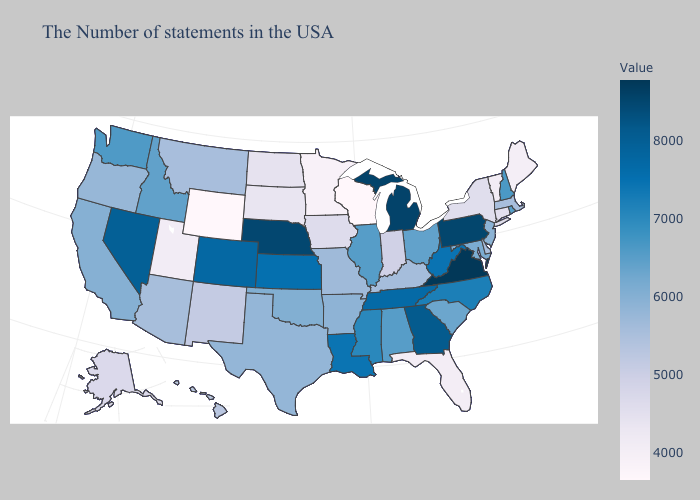Is the legend a continuous bar?
Write a very short answer. Yes. Among the states that border Arizona , does New Mexico have the lowest value?
Write a very short answer. No. Does Wyoming have the lowest value in the USA?
Write a very short answer. Yes. Which states have the lowest value in the West?
Concise answer only. Wyoming. Among the states that border Delaware , which have the lowest value?
Concise answer only. New Jersey. Does Texas have the highest value in the South?
Keep it brief. No. Does Massachusetts have the highest value in the Northeast?
Keep it brief. No. Does Iowa have a lower value than Rhode Island?
Answer briefly. Yes. 